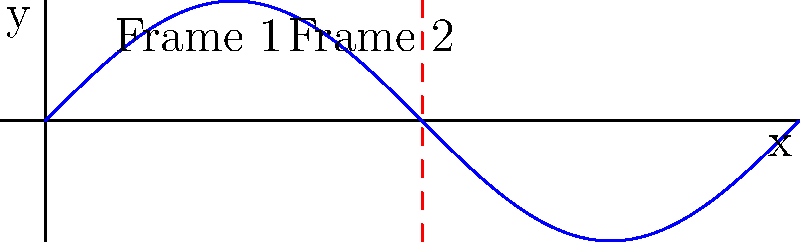In hand-drawn animation, consider a sequence of frames representing a character's motion. If we treat this sequence as a topological space, where each frame is a point and the continuity between frames defines the topology, what type of topological discontinuity would occur if there's a sudden jump in the character's position between two consecutive frames, as shown in the graph? To answer this question, let's break it down step-by-step:

1. In topology, continuity is a key concept. A function is continuous if small changes in the input result in small changes in the output.

2. In the context of animation frames:
   - Each frame can be considered a point in the topological space.
   - The "distance" between frames represents how similar or different they are.

3. In a smooth animation:
   - Consecutive frames are very similar, representing small, continuous changes.
   - This would be analogous to a continuous function in topology.

4. The graph shows a sudden jump at $x = \pi$:
   - This represents a significant change between two consecutive frames.
   - In topological terms, this is a discontinuity.

5. Types of discontinuities in topology:
   - Removable discontinuity: A "hole" that can be filled.
   - Jump discontinuity: A sudden change in value.
   - Infinite discontinuity: The function approaches infinity.

6. In this case:
   - The sudden change in the character's position is a abrupt, finite change.
   - This matches the characteristics of a jump discontinuity.

Therefore, the type of topological discontinuity that would occur in this situation is a jump discontinuity.
Answer: Jump discontinuity 